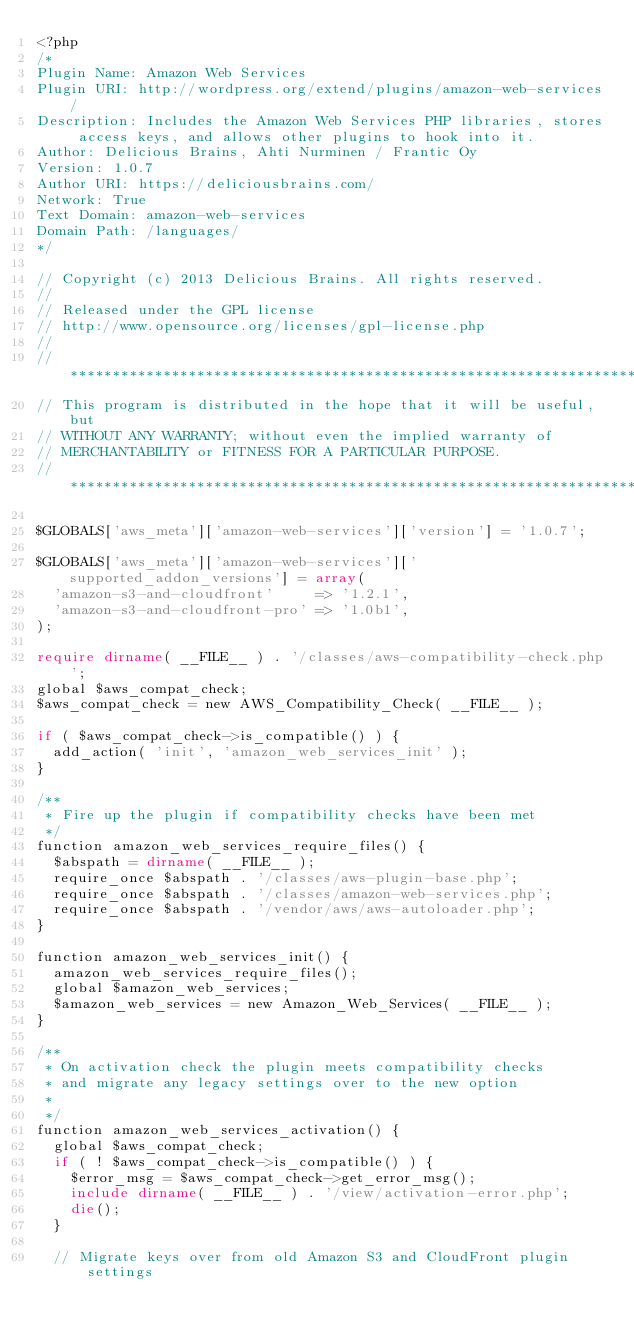<code> <loc_0><loc_0><loc_500><loc_500><_PHP_><?php
/*
Plugin Name: Amazon Web Services
Plugin URI: http://wordpress.org/extend/plugins/amazon-web-services/
Description: Includes the Amazon Web Services PHP libraries, stores access keys, and allows other plugins to hook into it.
Author: Delicious Brains, Ahti Nurminen / Frantic Oy
Version: 1.0.7
Author URI: https://deliciousbrains.com/
Network: True
Text Domain: amazon-web-services
Domain Path: /languages/
*/

// Copyright (c) 2013 Delicious Brains. All rights reserved.
//
// Released under the GPL license
// http://www.opensource.org/licenses/gpl-license.php
//
// **********************************************************************
// This program is distributed in the hope that it will be useful, but
// WITHOUT ANY WARRANTY; without even the implied warranty of
// MERCHANTABILITY or FITNESS FOR A PARTICULAR PURPOSE.
// **********************************************************************

$GLOBALS['aws_meta']['amazon-web-services']['version'] = '1.0.7';

$GLOBALS['aws_meta']['amazon-web-services']['supported_addon_versions'] = array(
	'amazon-s3-and-cloudfront'     => '1.2.1',
	'amazon-s3-and-cloudfront-pro' => '1.0b1',
);

require dirname( __FILE__ ) . '/classes/aws-compatibility-check.php';
global $aws_compat_check;
$aws_compat_check = new AWS_Compatibility_Check( __FILE__ );

if ( $aws_compat_check->is_compatible() ) {
	add_action( 'init', 'amazon_web_services_init' );
}

/**
 * Fire up the plugin if compatibility checks have been met
 */
function amazon_web_services_require_files() {
	$abspath = dirname( __FILE__ );
	require_once $abspath . '/classes/aws-plugin-base.php';
	require_once $abspath . '/classes/amazon-web-services.php';
	require_once $abspath . '/vendor/aws/aws-autoloader.php';
}

function amazon_web_services_init() {
	amazon_web_services_require_files();
	global $amazon_web_services;
	$amazon_web_services = new Amazon_Web_Services( __FILE__ );
}

/**
 * On activation check the plugin meets compatibility checks
 * and migrate any legacy settings over to the new option
 *
 */
function amazon_web_services_activation() {
	global $aws_compat_check;
	if ( ! $aws_compat_check->is_compatible() ) {
		$error_msg = $aws_compat_check->get_error_msg();
		include dirname( __FILE__ ) . '/view/activation-error.php';
		die();
	}

	// Migrate keys over from old Amazon S3 and CloudFront plugin settings</code> 